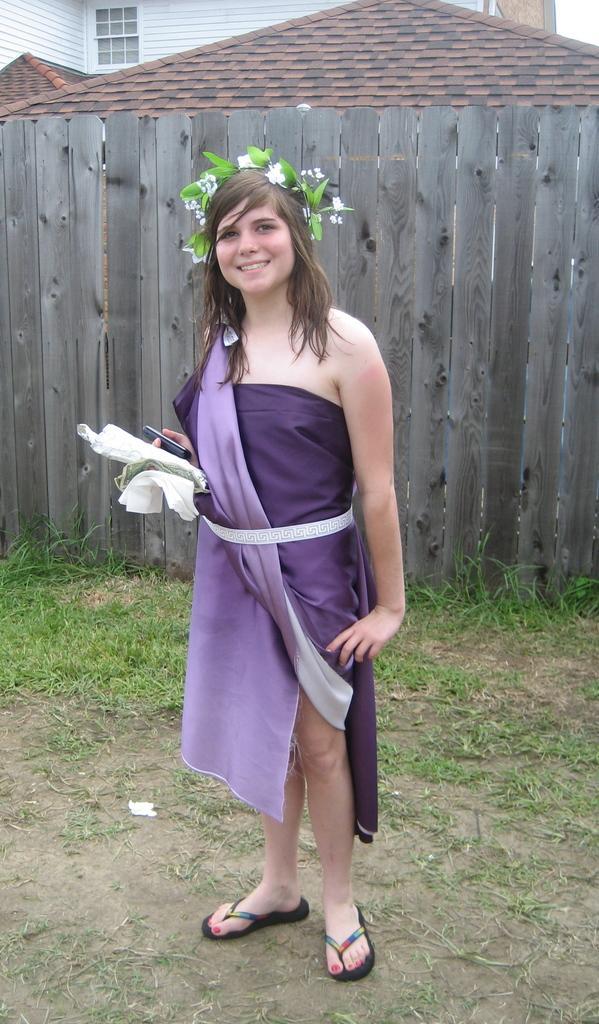How would you summarize this image in a sentence or two? In this image I can see a person standing and holding something and wearing a crown. Back I can see a fencing,houses,windows and green grass. 